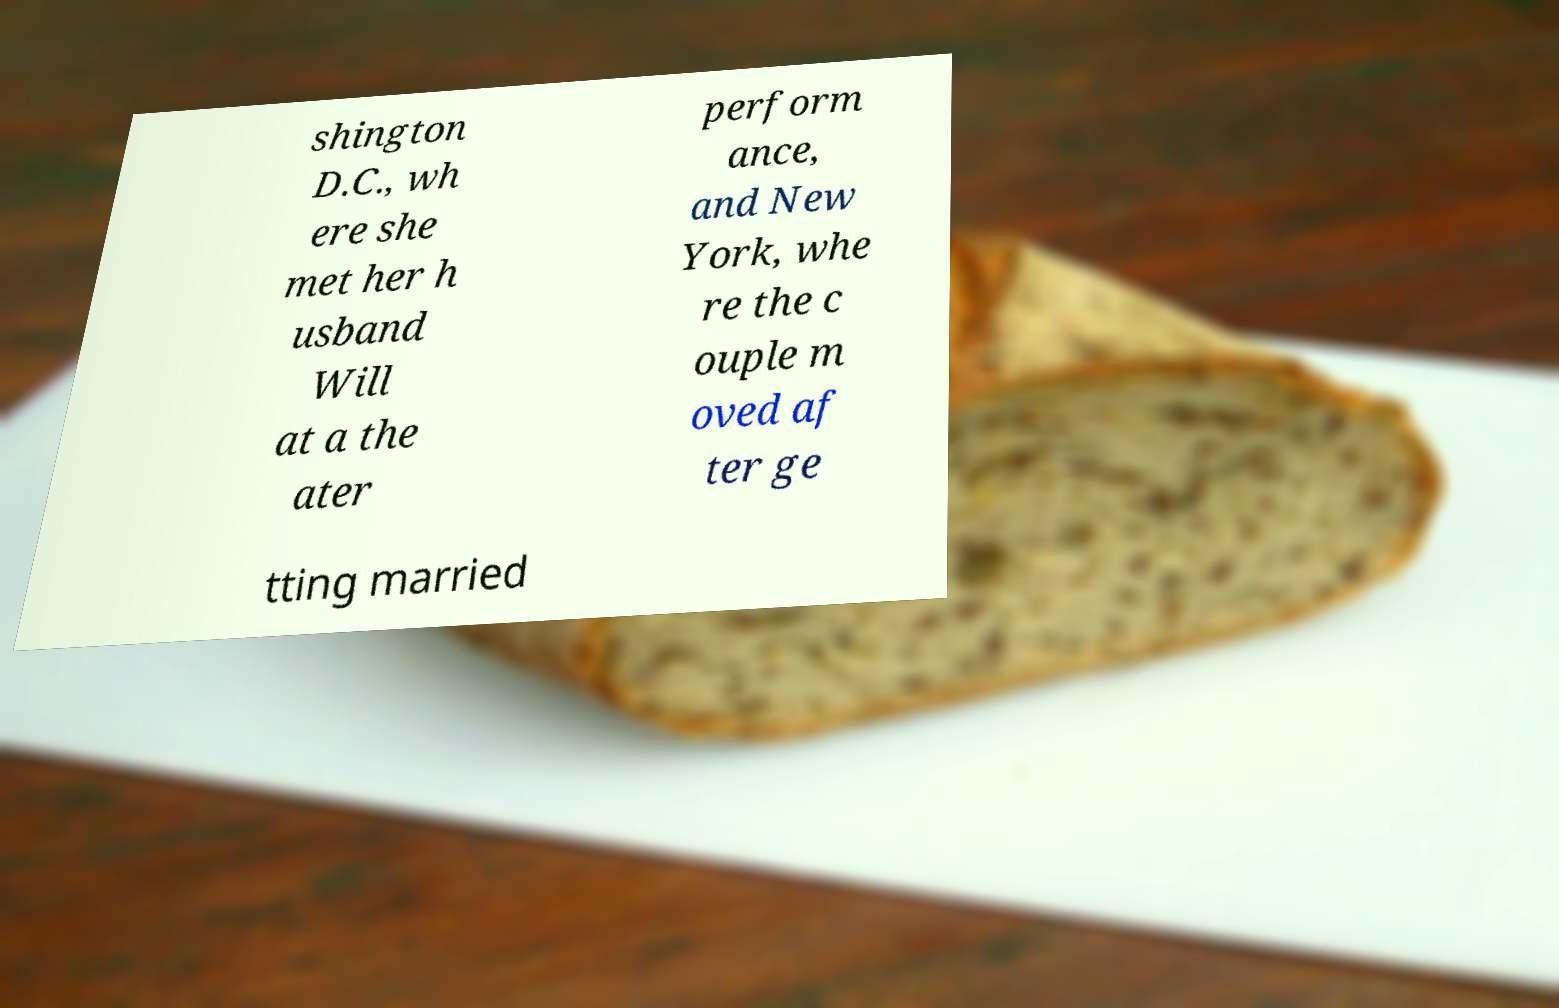For documentation purposes, I need the text within this image transcribed. Could you provide that? shington D.C., wh ere she met her h usband Will at a the ater perform ance, and New York, whe re the c ouple m oved af ter ge tting married 